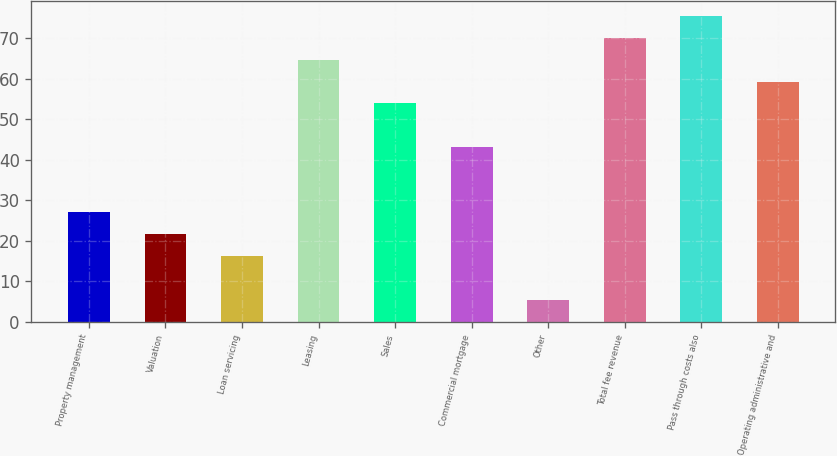Convert chart to OTSL. <chart><loc_0><loc_0><loc_500><loc_500><bar_chart><fcel>Property management<fcel>Valuation<fcel>Loan servicing<fcel>Leasing<fcel>Sales<fcel>Commercial mortgage<fcel>Other<fcel>Total fee revenue<fcel>Pass through costs also<fcel>Operating administrative and<nl><fcel>27<fcel>21.62<fcel>16.24<fcel>64.66<fcel>53.9<fcel>43.14<fcel>5.48<fcel>70.04<fcel>75.42<fcel>59.28<nl></chart> 